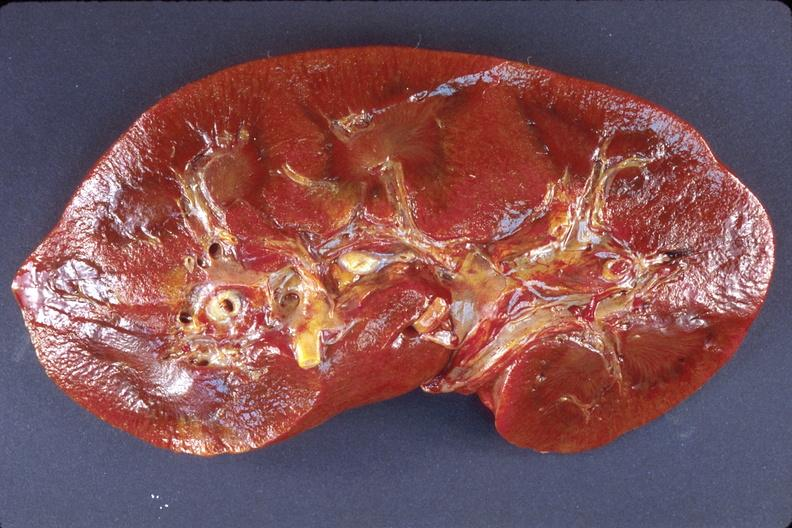where is this?
Answer the question using a single word or phrase. Urinary 